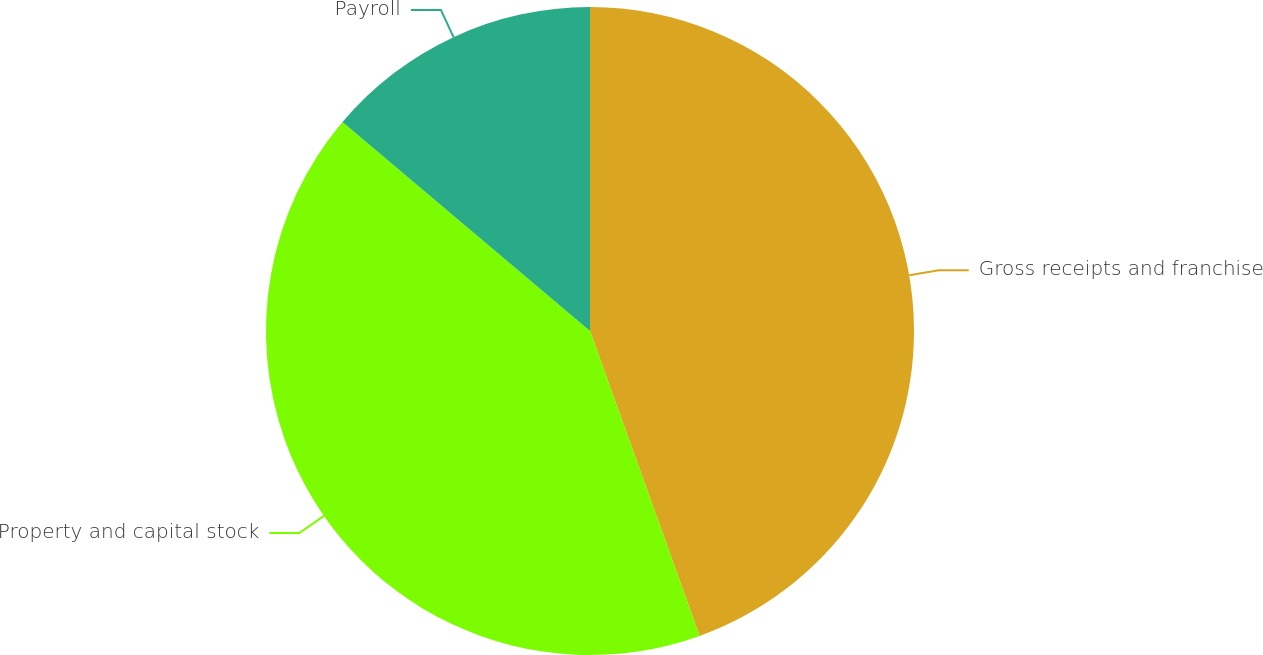Convert chart to OTSL. <chart><loc_0><loc_0><loc_500><loc_500><pie_chart><fcel>Gross receipts and franchise<fcel>Property and capital stock<fcel>Payroll<nl><fcel>44.51%<fcel>41.66%<fcel>13.84%<nl></chart> 